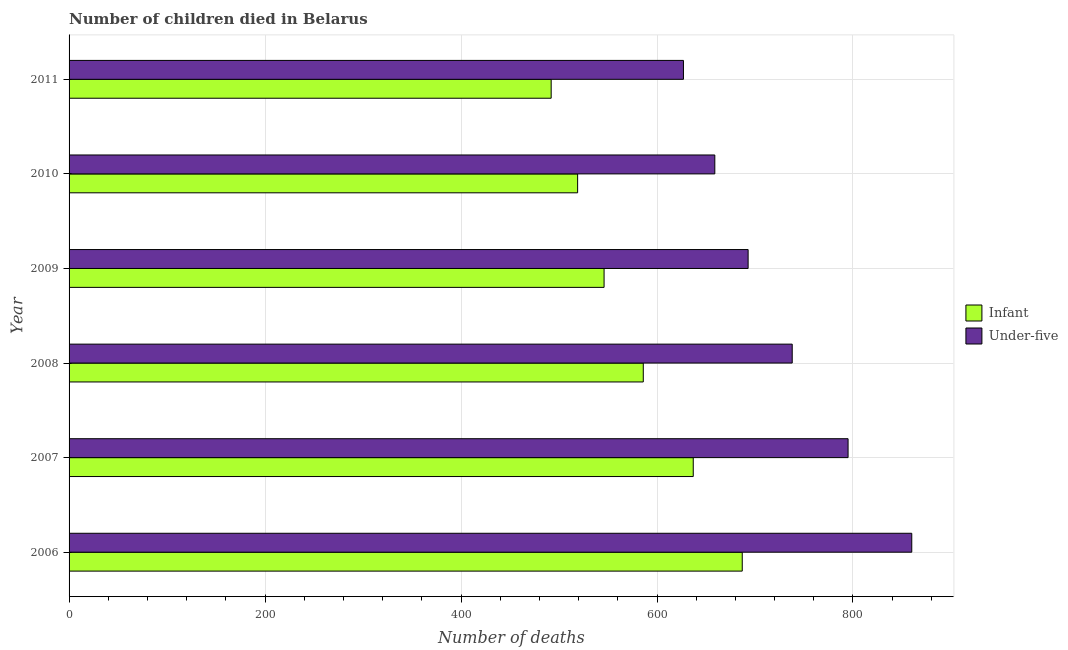How many different coloured bars are there?
Offer a very short reply. 2. How many bars are there on the 2nd tick from the top?
Offer a terse response. 2. In how many cases, is the number of bars for a given year not equal to the number of legend labels?
Ensure brevity in your answer.  0. What is the number of infant deaths in 2008?
Ensure brevity in your answer.  586. Across all years, what is the maximum number of infant deaths?
Offer a very short reply. 687. Across all years, what is the minimum number of under-five deaths?
Offer a terse response. 627. In which year was the number of under-five deaths minimum?
Offer a terse response. 2011. What is the total number of infant deaths in the graph?
Make the answer very short. 3467. What is the difference between the number of under-five deaths in 2006 and that in 2008?
Offer a terse response. 122. What is the difference between the number of under-five deaths in 2010 and the number of infant deaths in 2007?
Keep it short and to the point. 22. What is the average number of infant deaths per year?
Provide a short and direct response. 577.83. In the year 2011, what is the difference between the number of under-five deaths and number of infant deaths?
Make the answer very short. 135. In how many years, is the number of under-five deaths greater than 560 ?
Keep it short and to the point. 6. What is the ratio of the number of under-five deaths in 2007 to that in 2011?
Keep it short and to the point. 1.27. Is the number of infant deaths in 2007 less than that in 2008?
Make the answer very short. No. What is the difference between the highest and the second highest number of under-five deaths?
Your answer should be compact. 65. What is the difference between the highest and the lowest number of infant deaths?
Offer a terse response. 195. What does the 1st bar from the top in 2007 represents?
Provide a short and direct response. Under-five. What does the 1st bar from the bottom in 2010 represents?
Offer a very short reply. Infant. Are all the bars in the graph horizontal?
Ensure brevity in your answer.  Yes. Where does the legend appear in the graph?
Your answer should be compact. Center right. How are the legend labels stacked?
Keep it short and to the point. Vertical. What is the title of the graph?
Provide a succinct answer. Number of children died in Belarus. What is the label or title of the X-axis?
Provide a short and direct response. Number of deaths. What is the label or title of the Y-axis?
Your answer should be compact. Year. What is the Number of deaths in Infant in 2006?
Your answer should be very brief. 687. What is the Number of deaths of Under-five in 2006?
Provide a succinct answer. 860. What is the Number of deaths of Infant in 2007?
Provide a short and direct response. 637. What is the Number of deaths of Under-five in 2007?
Offer a terse response. 795. What is the Number of deaths of Infant in 2008?
Your response must be concise. 586. What is the Number of deaths of Under-five in 2008?
Offer a terse response. 738. What is the Number of deaths in Infant in 2009?
Keep it short and to the point. 546. What is the Number of deaths in Under-five in 2009?
Keep it short and to the point. 693. What is the Number of deaths of Infant in 2010?
Give a very brief answer. 519. What is the Number of deaths in Under-five in 2010?
Ensure brevity in your answer.  659. What is the Number of deaths of Infant in 2011?
Make the answer very short. 492. What is the Number of deaths of Under-five in 2011?
Your answer should be very brief. 627. Across all years, what is the maximum Number of deaths in Infant?
Ensure brevity in your answer.  687. Across all years, what is the maximum Number of deaths in Under-five?
Your response must be concise. 860. Across all years, what is the minimum Number of deaths in Infant?
Your answer should be compact. 492. Across all years, what is the minimum Number of deaths in Under-five?
Provide a succinct answer. 627. What is the total Number of deaths in Infant in the graph?
Offer a terse response. 3467. What is the total Number of deaths of Under-five in the graph?
Keep it short and to the point. 4372. What is the difference between the Number of deaths in Infant in 2006 and that in 2008?
Make the answer very short. 101. What is the difference between the Number of deaths in Under-five in 2006 and that in 2008?
Make the answer very short. 122. What is the difference between the Number of deaths of Infant in 2006 and that in 2009?
Provide a succinct answer. 141. What is the difference between the Number of deaths in Under-five in 2006 and that in 2009?
Provide a short and direct response. 167. What is the difference between the Number of deaths of Infant in 2006 and that in 2010?
Ensure brevity in your answer.  168. What is the difference between the Number of deaths of Under-five in 2006 and that in 2010?
Offer a very short reply. 201. What is the difference between the Number of deaths in Infant in 2006 and that in 2011?
Make the answer very short. 195. What is the difference between the Number of deaths in Under-five in 2006 and that in 2011?
Your answer should be compact. 233. What is the difference between the Number of deaths of Under-five in 2007 and that in 2008?
Your response must be concise. 57. What is the difference between the Number of deaths in Infant in 2007 and that in 2009?
Give a very brief answer. 91. What is the difference between the Number of deaths of Under-five in 2007 and that in 2009?
Your answer should be very brief. 102. What is the difference between the Number of deaths in Infant in 2007 and that in 2010?
Provide a short and direct response. 118. What is the difference between the Number of deaths in Under-five in 2007 and that in 2010?
Ensure brevity in your answer.  136. What is the difference between the Number of deaths of Infant in 2007 and that in 2011?
Provide a short and direct response. 145. What is the difference between the Number of deaths in Under-five in 2007 and that in 2011?
Ensure brevity in your answer.  168. What is the difference between the Number of deaths of Under-five in 2008 and that in 2009?
Ensure brevity in your answer.  45. What is the difference between the Number of deaths of Infant in 2008 and that in 2010?
Your response must be concise. 67. What is the difference between the Number of deaths in Under-five in 2008 and that in 2010?
Offer a very short reply. 79. What is the difference between the Number of deaths of Infant in 2008 and that in 2011?
Keep it short and to the point. 94. What is the difference between the Number of deaths in Under-five in 2008 and that in 2011?
Your response must be concise. 111. What is the difference between the Number of deaths of Infant in 2009 and that in 2010?
Your answer should be compact. 27. What is the difference between the Number of deaths in Under-five in 2009 and that in 2011?
Provide a short and direct response. 66. What is the difference between the Number of deaths in Infant in 2006 and the Number of deaths in Under-five in 2007?
Make the answer very short. -108. What is the difference between the Number of deaths of Infant in 2006 and the Number of deaths of Under-five in 2008?
Give a very brief answer. -51. What is the difference between the Number of deaths of Infant in 2007 and the Number of deaths of Under-five in 2008?
Your answer should be compact. -101. What is the difference between the Number of deaths of Infant in 2007 and the Number of deaths of Under-five in 2009?
Your answer should be compact. -56. What is the difference between the Number of deaths of Infant in 2007 and the Number of deaths of Under-five in 2011?
Keep it short and to the point. 10. What is the difference between the Number of deaths in Infant in 2008 and the Number of deaths in Under-five in 2009?
Offer a terse response. -107. What is the difference between the Number of deaths of Infant in 2008 and the Number of deaths of Under-five in 2010?
Your response must be concise. -73. What is the difference between the Number of deaths in Infant in 2008 and the Number of deaths in Under-five in 2011?
Give a very brief answer. -41. What is the difference between the Number of deaths of Infant in 2009 and the Number of deaths of Under-five in 2010?
Your answer should be compact. -113. What is the difference between the Number of deaths of Infant in 2009 and the Number of deaths of Under-five in 2011?
Your answer should be compact. -81. What is the difference between the Number of deaths in Infant in 2010 and the Number of deaths in Under-five in 2011?
Offer a terse response. -108. What is the average Number of deaths in Infant per year?
Keep it short and to the point. 577.83. What is the average Number of deaths of Under-five per year?
Offer a terse response. 728.67. In the year 2006, what is the difference between the Number of deaths in Infant and Number of deaths in Under-five?
Ensure brevity in your answer.  -173. In the year 2007, what is the difference between the Number of deaths in Infant and Number of deaths in Under-five?
Provide a short and direct response. -158. In the year 2008, what is the difference between the Number of deaths in Infant and Number of deaths in Under-five?
Offer a very short reply. -152. In the year 2009, what is the difference between the Number of deaths of Infant and Number of deaths of Under-five?
Your answer should be very brief. -147. In the year 2010, what is the difference between the Number of deaths in Infant and Number of deaths in Under-five?
Your answer should be compact. -140. In the year 2011, what is the difference between the Number of deaths in Infant and Number of deaths in Under-five?
Your answer should be compact. -135. What is the ratio of the Number of deaths in Infant in 2006 to that in 2007?
Offer a very short reply. 1.08. What is the ratio of the Number of deaths of Under-five in 2006 to that in 2007?
Your answer should be compact. 1.08. What is the ratio of the Number of deaths in Infant in 2006 to that in 2008?
Make the answer very short. 1.17. What is the ratio of the Number of deaths of Under-five in 2006 to that in 2008?
Your response must be concise. 1.17. What is the ratio of the Number of deaths of Infant in 2006 to that in 2009?
Provide a succinct answer. 1.26. What is the ratio of the Number of deaths of Under-five in 2006 to that in 2009?
Your answer should be very brief. 1.24. What is the ratio of the Number of deaths in Infant in 2006 to that in 2010?
Offer a terse response. 1.32. What is the ratio of the Number of deaths in Under-five in 2006 to that in 2010?
Make the answer very short. 1.3. What is the ratio of the Number of deaths in Infant in 2006 to that in 2011?
Your response must be concise. 1.4. What is the ratio of the Number of deaths in Under-five in 2006 to that in 2011?
Your response must be concise. 1.37. What is the ratio of the Number of deaths of Infant in 2007 to that in 2008?
Your answer should be compact. 1.09. What is the ratio of the Number of deaths in Under-five in 2007 to that in 2008?
Offer a terse response. 1.08. What is the ratio of the Number of deaths in Under-five in 2007 to that in 2009?
Your answer should be compact. 1.15. What is the ratio of the Number of deaths in Infant in 2007 to that in 2010?
Your answer should be very brief. 1.23. What is the ratio of the Number of deaths in Under-five in 2007 to that in 2010?
Provide a short and direct response. 1.21. What is the ratio of the Number of deaths in Infant in 2007 to that in 2011?
Ensure brevity in your answer.  1.29. What is the ratio of the Number of deaths of Under-five in 2007 to that in 2011?
Keep it short and to the point. 1.27. What is the ratio of the Number of deaths in Infant in 2008 to that in 2009?
Make the answer very short. 1.07. What is the ratio of the Number of deaths of Under-five in 2008 to that in 2009?
Make the answer very short. 1.06. What is the ratio of the Number of deaths in Infant in 2008 to that in 2010?
Give a very brief answer. 1.13. What is the ratio of the Number of deaths in Under-five in 2008 to that in 2010?
Your answer should be very brief. 1.12. What is the ratio of the Number of deaths in Infant in 2008 to that in 2011?
Keep it short and to the point. 1.19. What is the ratio of the Number of deaths of Under-five in 2008 to that in 2011?
Keep it short and to the point. 1.18. What is the ratio of the Number of deaths of Infant in 2009 to that in 2010?
Provide a succinct answer. 1.05. What is the ratio of the Number of deaths of Under-five in 2009 to that in 2010?
Your answer should be compact. 1.05. What is the ratio of the Number of deaths in Infant in 2009 to that in 2011?
Your answer should be very brief. 1.11. What is the ratio of the Number of deaths of Under-five in 2009 to that in 2011?
Provide a short and direct response. 1.11. What is the ratio of the Number of deaths of Infant in 2010 to that in 2011?
Make the answer very short. 1.05. What is the ratio of the Number of deaths in Under-five in 2010 to that in 2011?
Keep it short and to the point. 1.05. What is the difference between the highest and the second highest Number of deaths in Under-five?
Offer a terse response. 65. What is the difference between the highest and the lowest Number of deaths of Infant?
Offer a terse response. 195. What is the difference between the highest and the lowest Number of deaths of Under-five?
Offer a terse response. 233. 